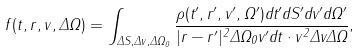Convert formula to latex. <formula><loc_0><loc_0><loc_500><loc_500>f ( t , { r } , v , \Delta \Omega ) = \int _ { \Delta S , \Delta v , \Delta \Omega _ { 0 } } \frac { \rho ( t ^ { \prime } , { r } ^ { \prime } , v ^ { \prime } , \Omega ^ { \prime } ) d t ^ { \prime } d S ^ { \prime } d v ^ { \prime } d \Omega ^ { \prime } } { | { r } - { r } ^ { \prime } | ^ { 2 } \Delta \Omega _ { 0 } v ^ { \prime } d t \cdot v ^ { 2 } \Delta v \Delta \Omega } ,</formula> 